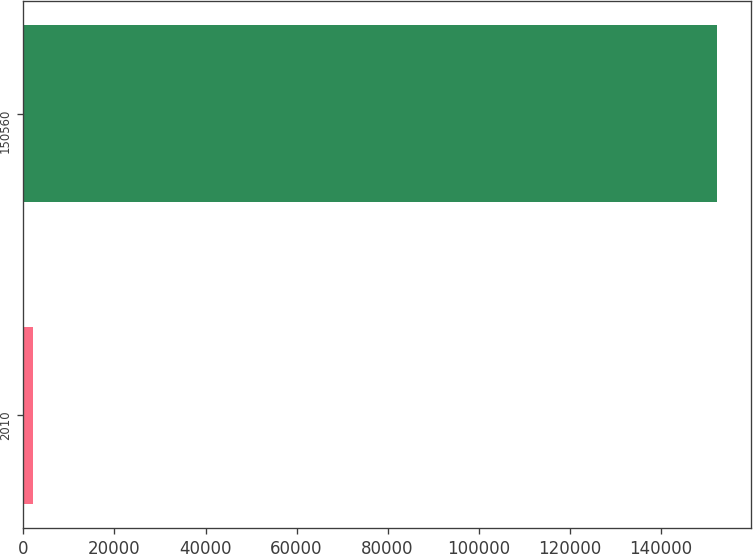<chart> <loc_0><loc_0><loc_500><loc_500><bar_chart><fcel>2010<fcel>150560<nl><fcel>2009<fcel>152340<nl></chart> 